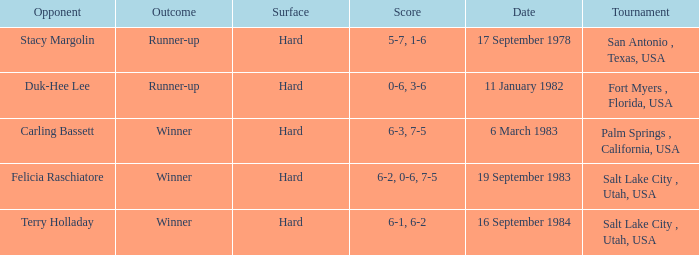Who was the opponent for the match were the outcome was runner-up and the score was 5-7, 1-6? Stacy Margolin. 